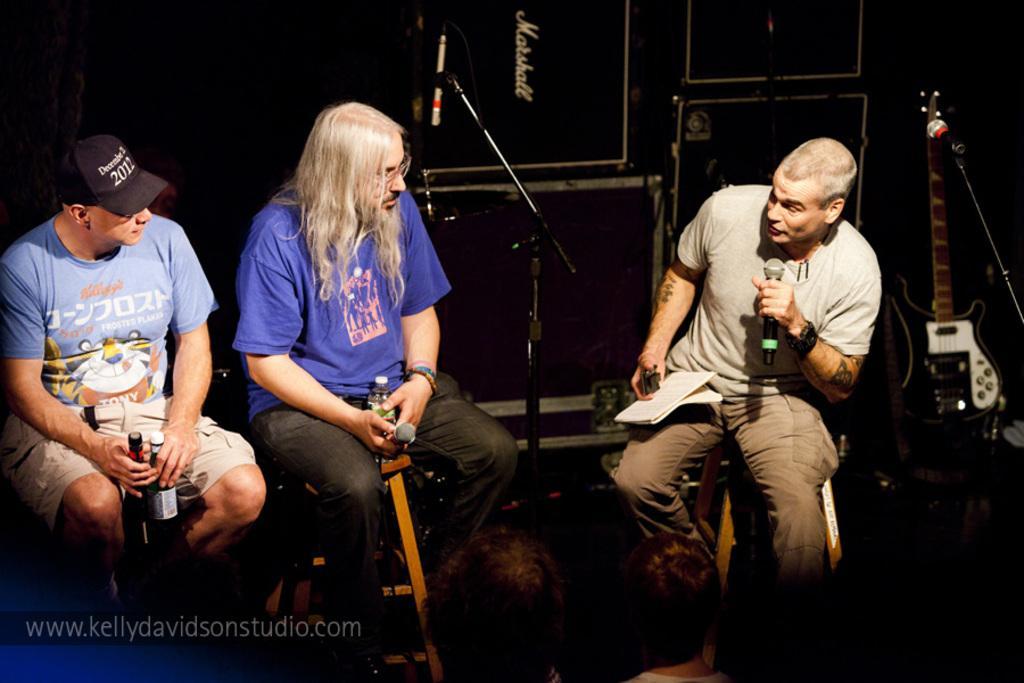In one or two sentences, can you explain what this image depicts? In this image we can see three people sitting on the stools, a person is holding a mic, papers and an object, a person is holding a mic and a bottle and a person is holding bottles, there is a mic with stand in front of the person, and on the right side there is a guitar and mic and in the background there are speakers. 